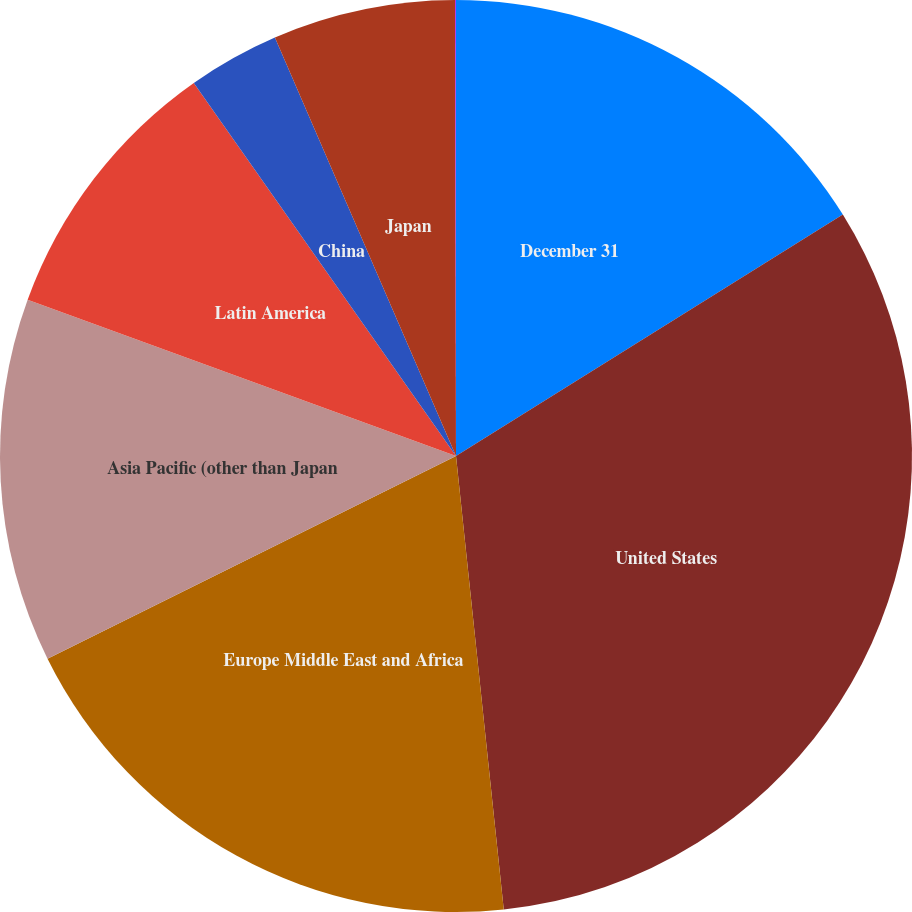Convert chart. <chart><loc_0><loc_0><loc_500><loc_500><pie_chart><fcel>December 31<fcel>United States<fcel>Europe Middle East and Africa<fcel>Asia Pacific (other than Japan<fcel>Latin America<fcel>China<fcel>Japan<fcel>Other<nl><fcel>16.12%<fcel>32.21%<fcel>19.34%<fcel>12.9%<fcel>9.68%<fcel>3.25%<fcel>6.47%<fcel>0.03%<nl></chart> 